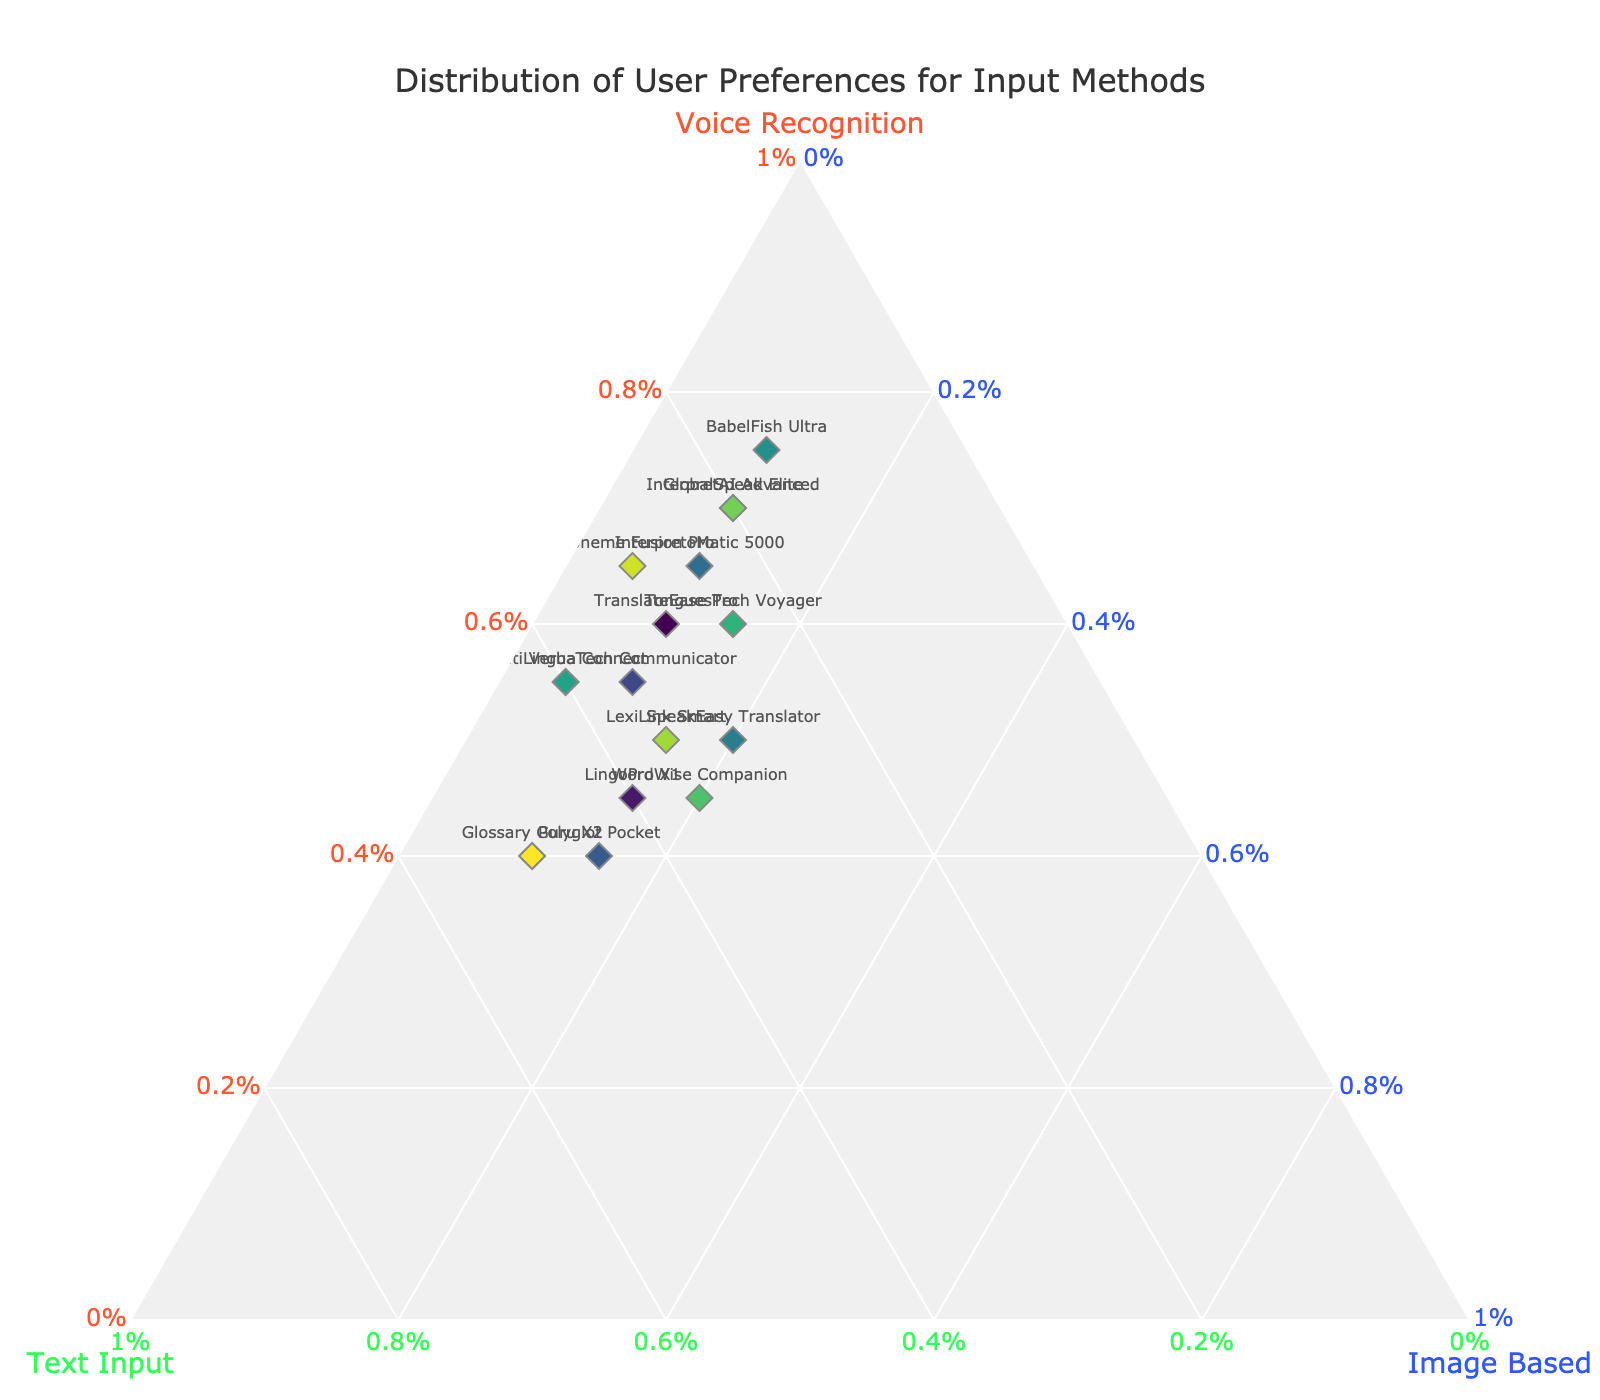What is the title of the ternary plot? The title of the ternary plot is displayed prominently at the top of the figure.
Answer: Distribution of User Preferences for Input Methods What are the three axes labeled as? Each axis is labeled at its end. The labels are 'Voice Recognition', 'Text Input', and 'Image Based'.
Answer: Voice Recognition, Text Input, Image Based How many devices are represented in the plot? Count the number of markers (dots) in the ternary plot. Each marker represents one device.
Answer: 15 Which device has the highest preference for voice recognition? Identify the dot closest to the 'Voice Recognition' vertex of the ternary plot, i.e., the device with the highest percentage in the 'Voice Recognition' axis.
Answer: BabelFish Ultra Which device has equal preferences for text input and image-based translation? Find the marker located at a point where the 'Text Input' and 'Image Based' axes values are the same. The values should also sum up to the remaining percentage after considering 'Voice Recognition'.
Answer: SpeakEasy Translator What is the overall trend for the preference towards image-based translation? Examine the distribution of markers along the 'Image Based' axis. See if the majority are closer to lower or higher percentages.
Answer: Preferences for image-based translation tend to be lower, mostly around 5-20% Which two devices have a similar distribution of preferences for input methods? Look for two markers placed close to each other in the ternary plot. Similar positions indicate similar preference distributions.
Answer: TonguesTech Voyager and LexiLink Smart What's the sum of text input and image-based translation preferences for GlobalSpeak Elite? Add the percentages of 'Text Input' and 'Image Based' for GlobalSpeak Elite.
Answer: 20% + 10% = 30% Which device has the closest ratio of voice recognition to text input? Compare the voice recognition and text input percentages for each device to find the smallest difference, indicating the closest ratio.
Answer: LingoPro X1 What is the median value of voice recognition preference among all devices? Arrange the 'Voice Recognition' percentages in ascending order and find the middle value.
Answer: 60% 